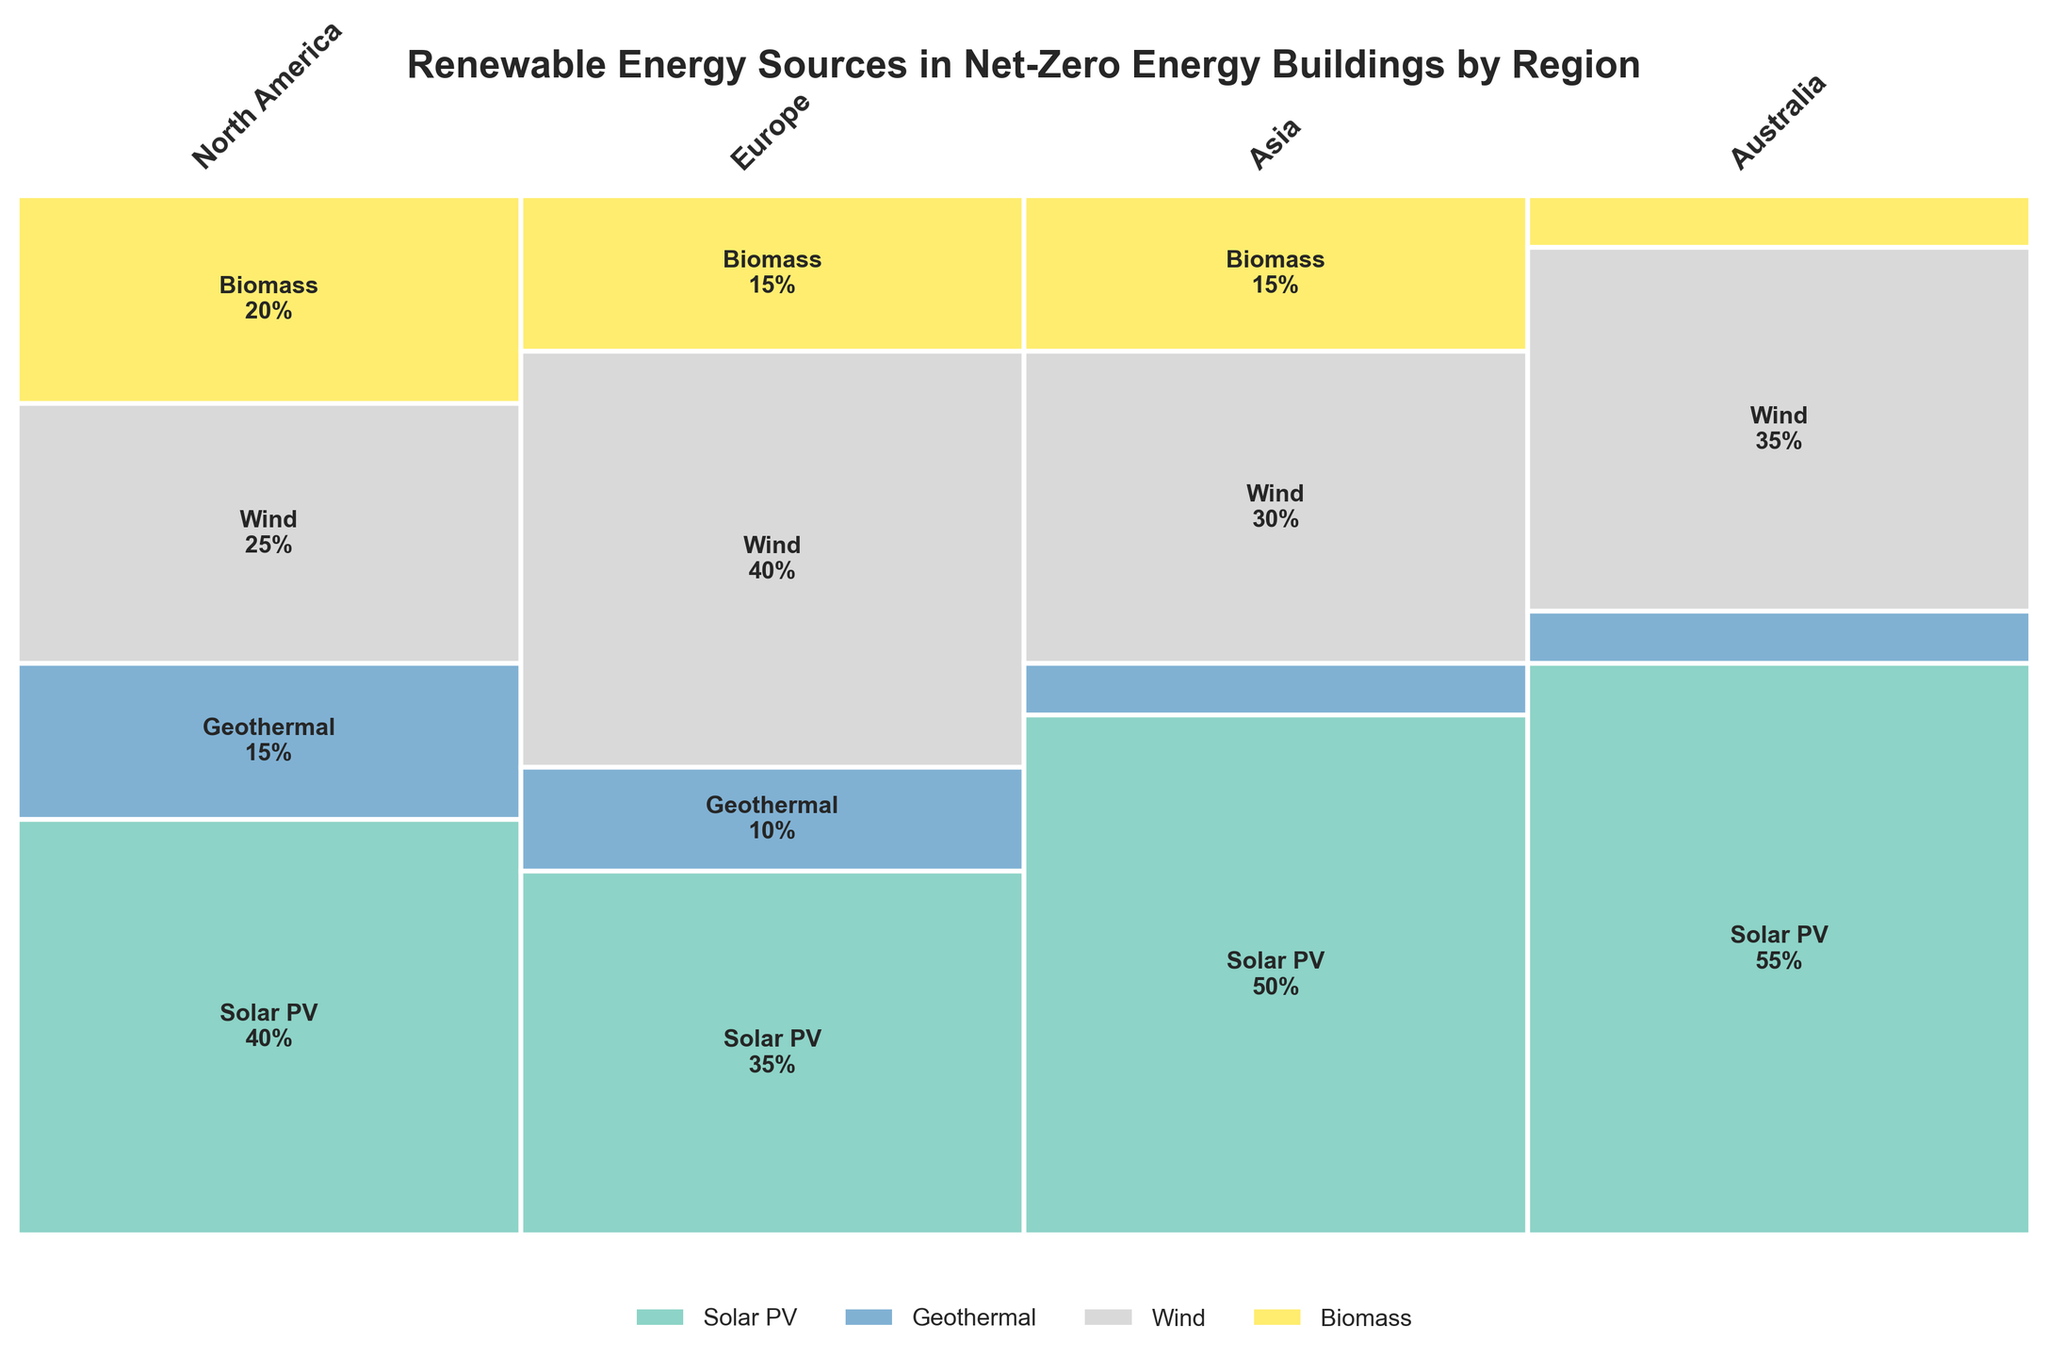What region has the highest percentage of Solar PV? By observing the plot, we can see that Australia has the largest section dedicated to Solar PV, labeled with 55%.
Answer: Australia What is the smallest renewable energy source in North America? From the plot, the smallest segment for North America is labeled Geothermal with 15%.
Answer: Geothermal Which region uses Wind energy the most? The plot shows that Europe has the largest segment labeled Wind, with 40%.
Answer: Europe What's the total percentage of Geothermal energy used in Asia and Australia? By checking the plot, Geothermal has 5% in both Asia and Australia. Summing them up gives 5% + 5% = 10%.
Answer: 10% Between North America and Europe, which has a higher usage of Biomass? Comparing the Biomass segments from the plot, North America has 20% while Europe has 15%, making North America's usage higher.
Answer: North America What energy source is most consistently used across all regions? By observing the plot, Solar PV is used across all regions with generally high percentages – 40%, 35%, 50%, and 55% respectively.
Answer: Solar PV How does the percentage of Wind energy in Europe compare to that in Asia? The plot shows that Europe has 40% Wind energy, while Asia has 30%. Thus, Europe has 10% more Wind energy compared to Asia.
Answer: Europe has 10% more What is the average percentage of Biomass energy usage across all regions? Adding up the Biomass percentages: 20% (North America) + 15% (Europe) + 15% (Asia) + 5% (Australia) = 55%. Dividing by the number of regions, 55% / 4 = 13.75%.
Answer: 13.75% Based on the plot, which region has the most varied renewable energy usage? By observing the heights of the segments, North America has more evenly distributed percentages among four energy sources: 40%, 15%, 25%, and 20%, indicating the most varied usage.
Answer: North America Is there any region that does not use Biomass significantly? The plot indicates Australia has the smallest Biomass percentage of 5%, making it insignificant compared to other regions.
Answer: Australia 